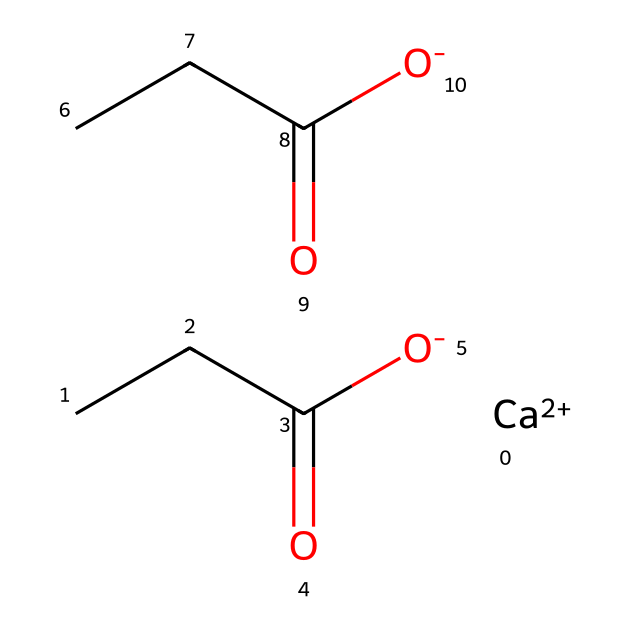what is the total number of carbon atoms in the chemical? By examining the SMILES representation, we can see that there are three instances of "CCC" which denote three carbon atoms each, along with two acetic acid functional groups that each contribute one carbon atom. Therefore, 3 + 2 = 5 carbon atoms in total.
Answer: five how many oxygen atoms are present in the structure? The chemical structure shows the presence of two carboxylic acid groups (CCC(=O)[O-]), and each carboxylic group contributes 2 oxygen atoms. Since there are two of these groups, we have 2 * 2 = 4 oxygen atoms total.
Answer: four what role does calcium play in this chemical? The presence of "[Ca++]" indicates that calcium is present in its divalent cation form, which typically acts as a stabilizing agent or a catalyst in organometallic compounds.
Answer: stabilizing agent how many total hydrogen atoms are present in the chemical? To count the hydrogen atoms, we look at the hydrogen associated with each carbon and analyze the bonding structure. Each CCC contributes three hydrogen atoms minus any lost to functional group bonding. Based on the arrangement, there are 10 hydrogen atoms total in this molecule.
Answer: ten is this chemical polar or nonpolar, and why? The presence of the carboxylic acid groups introduces significant polarity due to the electronegative oxygens and the ability to form hydrogen bonds. Thus, the overall structure is polar.
Answer: polar what type of organometallic bond is present in this compound? The chemical structure shows a calcium ion associated with organic groups, which represents an ionic bond between the metal (calcium) and the carbon-containing compounds (carboxylates).
Answer: ionic bond how does this compound likely affect the stability of paper in libraries? The presence of calcium and carboxylate groups suggests that it can help to neutralize acids in paper, thus prolonging the lifespan and stability of paper artifacts by preventing deterioration.
Answer: prolongs lifespan 